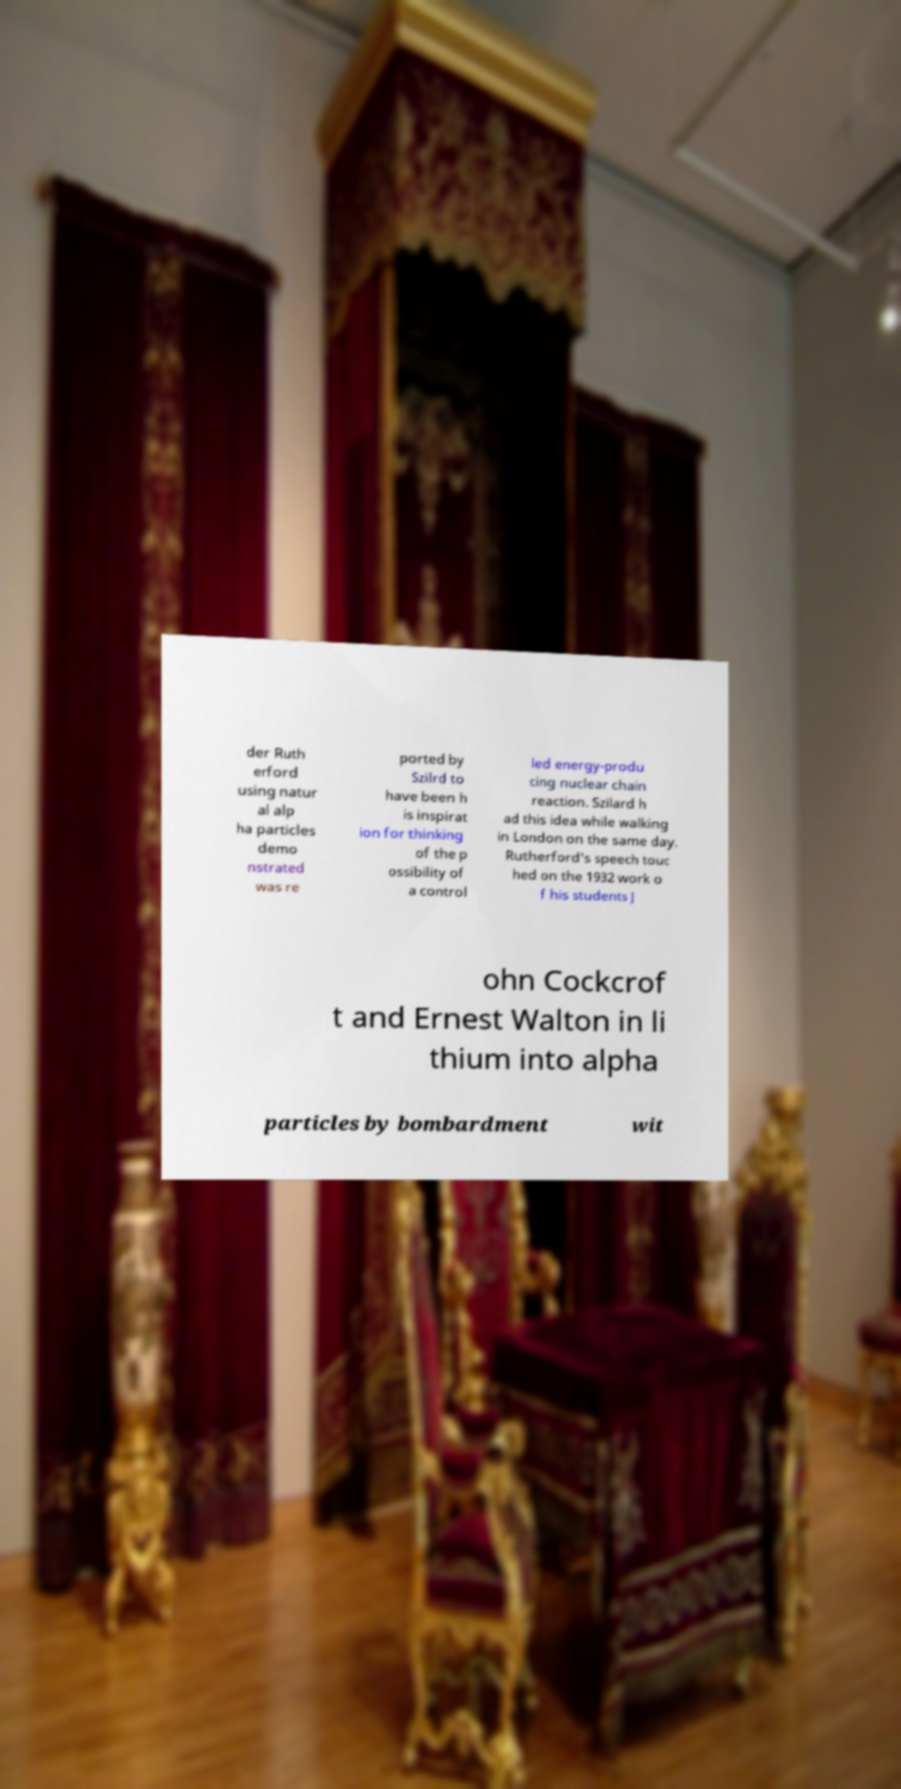Could you extract and type out the text from this image? der Ruth erford using natur al alp ha particles demo nstrated was re ported by Szilrd to have been h is inspirat ion for thinking of the p ossibility of a control led energy-produ cing nuclear chain reaction. Szilard h ad this idea while walking in London on the same day. Rutherford's speech touc hed on the 1932 work o f his students J ohn Cockcrof t and Ernest Walton in li thium into alpha particles by bombardment wit 